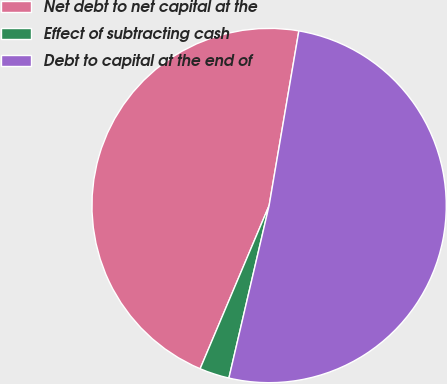Convert chart to OTSL. <chart><loc_0><loc_0><loc_500><loc_500><pie_chart><fcel>Net debt to net capital at the<fcel>Effect of subtracting cash<fcel>Debt to capital at the end of<nl><fcel>46.32%<fcel>2.72%<fcel>50.96%<nl></chart> 